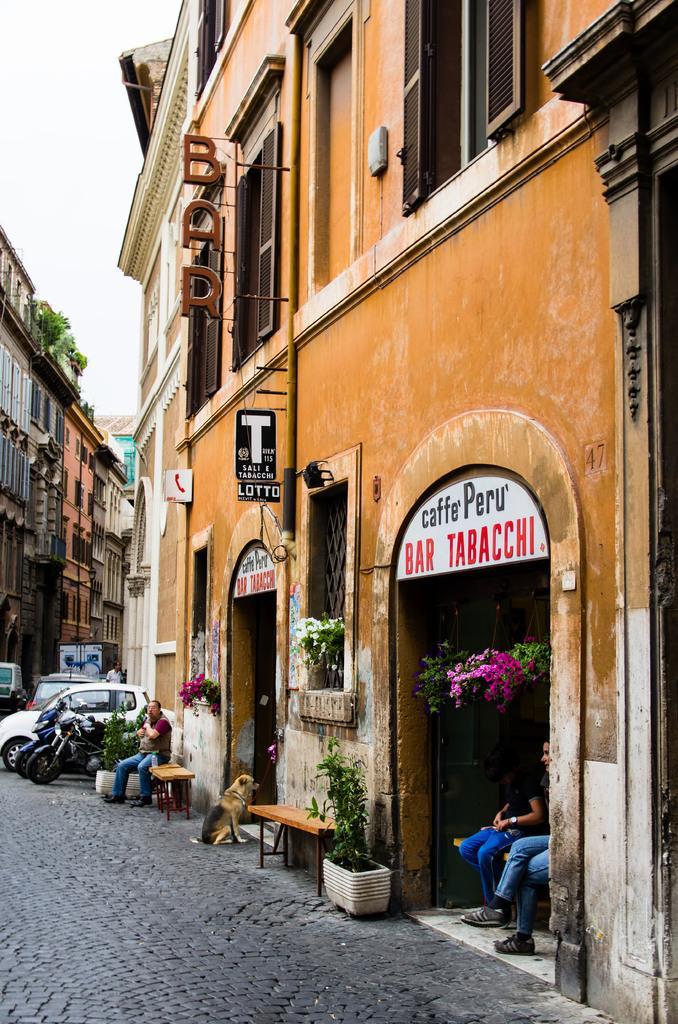Can you describe this image briefly? Three persons sitting on the bench. We can see dog,building,vehicles on the road,plant,city. 